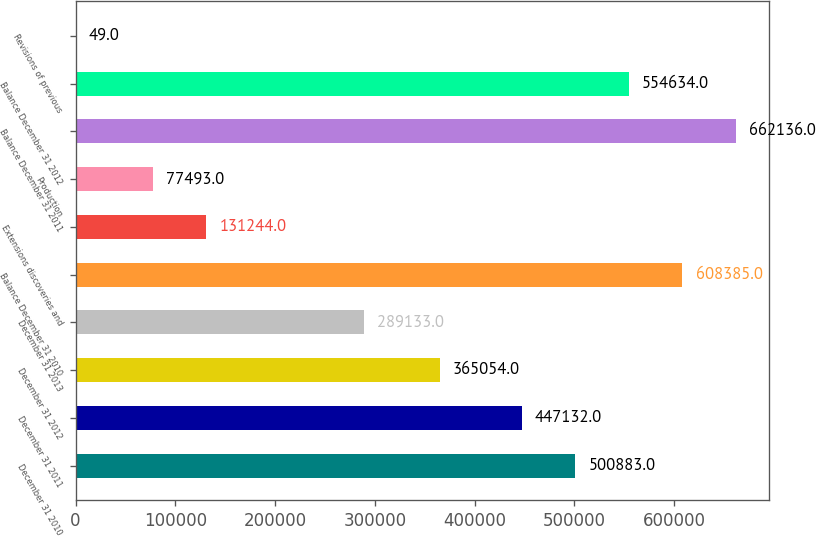Convert chart. <chart><loc_0><loc_0><loc_500><loc_500><bar_chart><fcel>December 31 2010<fcel>December 31 2011<fcel>December 31 2012<fcel>December 31 2013<fcel>Balance December 31 2010<fcel>Extensions discoveries and<fcel>Production<fcel>Balance December 31 2011<fcel>Balance December 31 2012<fcel>Revisions of previous<nl><fcel>500883<fcel>447132<fcel>365054<fcel>289133<fcel>608385<fcel>131244<fcel>77493<fcel>662136<fcel>554634<fcel>49<nl></chart> 